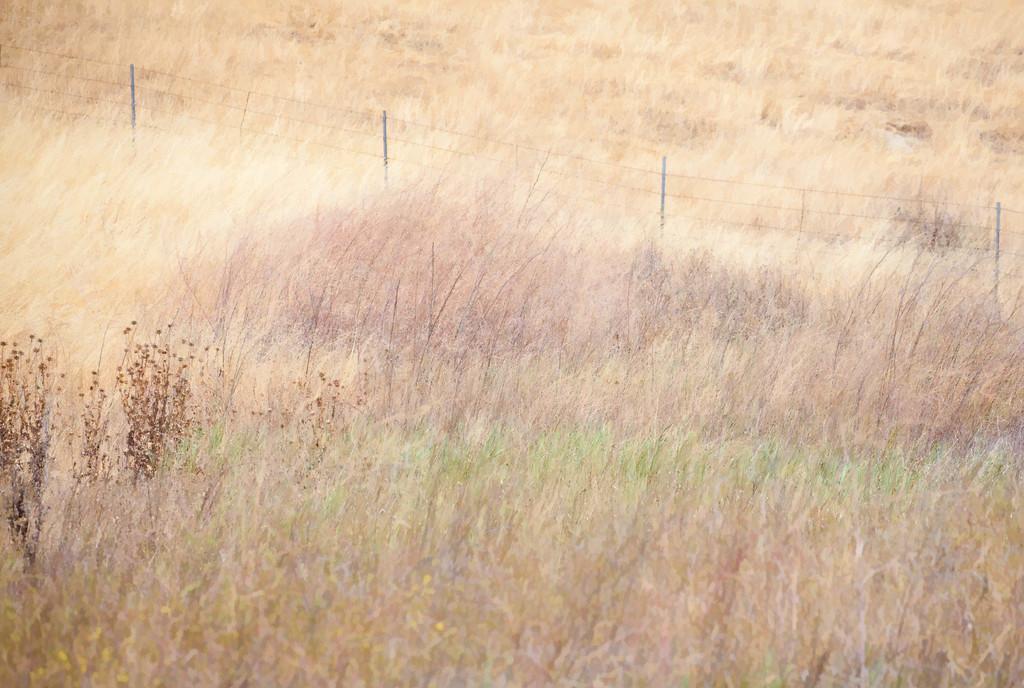Describe this image in one or two sentences. In this picture we can see fencing, plants, grass are there. 